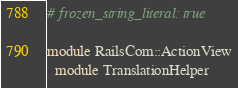Convert code to text. <code><loc_0><loc_0><loc_500><loc_500><_Ruby_># frozen_string_literal: true

module RailsCom::ActionView
  module TranslationHelper
</code> 